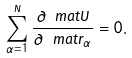Convert formula to latex. <formula><loc_0><loc_0><loc_500><loc_500>\sum _ { \alpha = 1 } ^ { N } \frac { \partial \ m a t { U } } { \partial \ m a t { r } _ { \alpha } } = 0 .</formula> 